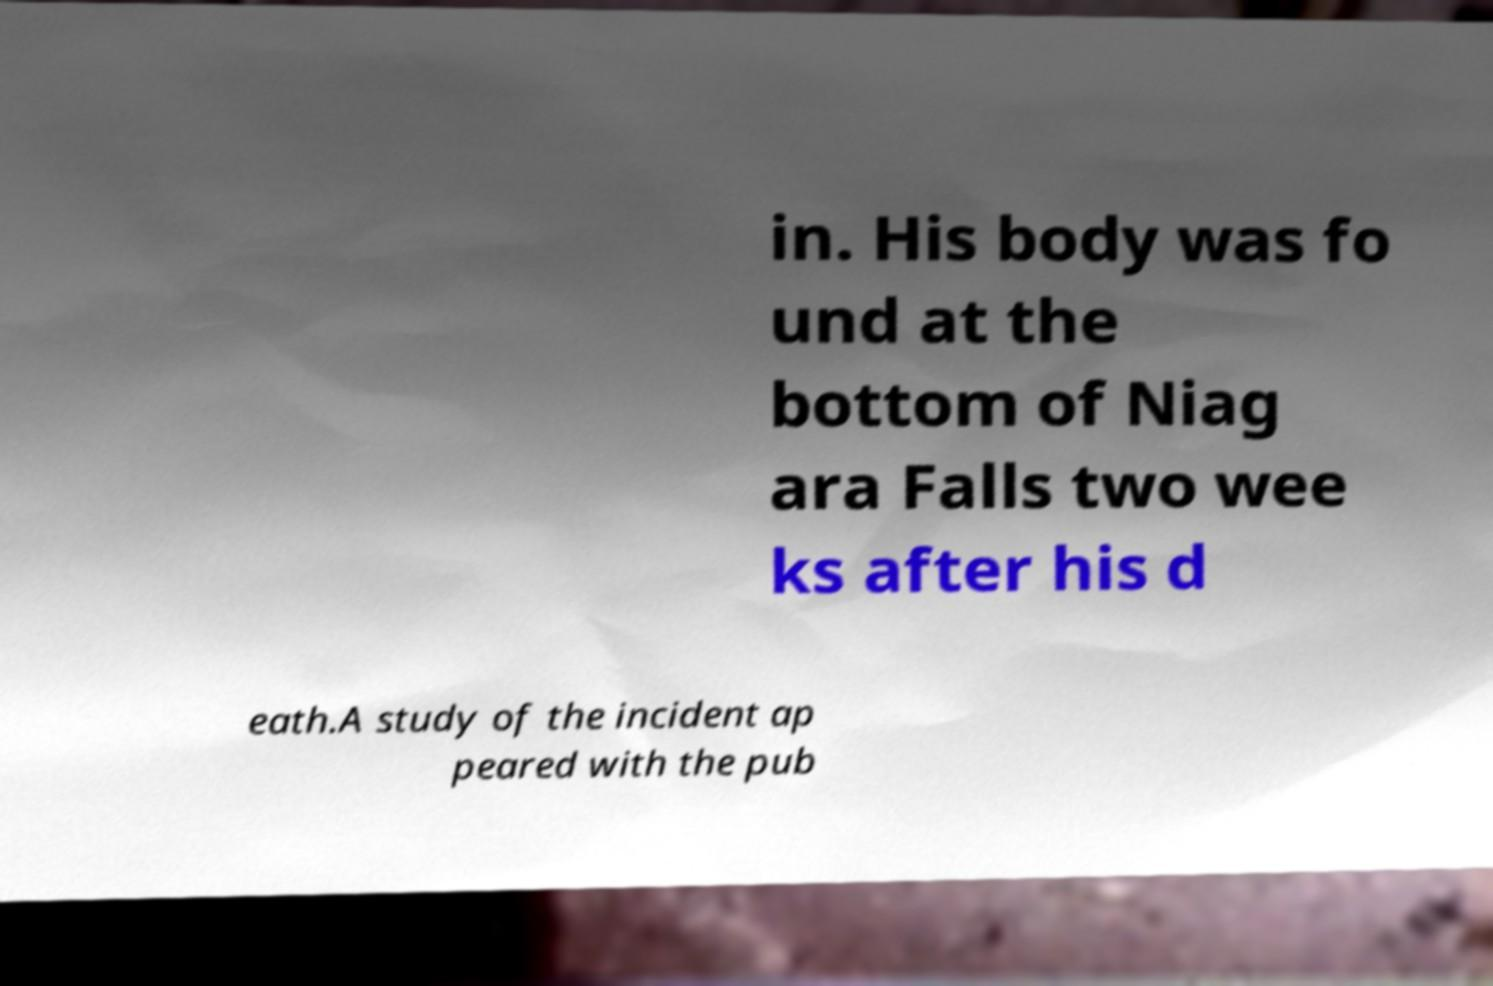What messages or text are displayed in this image? I need them in a readable, typed format. in. His body was fo und at the bottom of Niag ara Falls two wee ks after his d eath.A study of the incident ap peared with the pub 